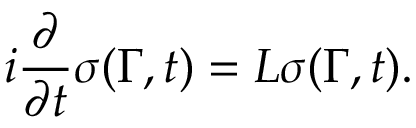<formula> <loc_0><loc_0><loc_500><loc_500>i { \frac { \partial } { \partial t } } \sigma ( \Gamma , t ) = L \sigma ( \Gamma , t ) .</formula> 